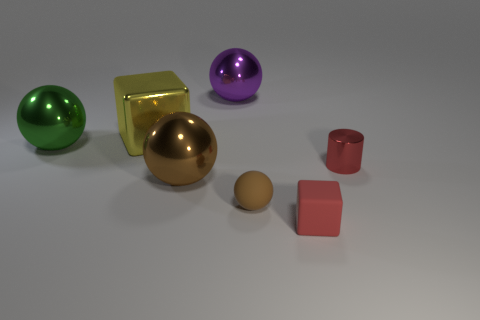Subtract all metal balls. How many balls are left? 1 Add 3 purple shiny balls. How many objects exist? 10 Subtract all blue spheres. Subtract all purple cubes. How many spheres are left? 4 Subtract all cylinders. How many objects are left? 6 Add 4 big yellow objects. How many big yellow objects are left? 5 Add 3 yellow blocks. How many yellow blocks exist? 4 Subtract 0 gray spheres. How many objects are left? 7 Subtract all yellow metallic cylinders. Subtract all large brown balls. How many objects are left? 6 